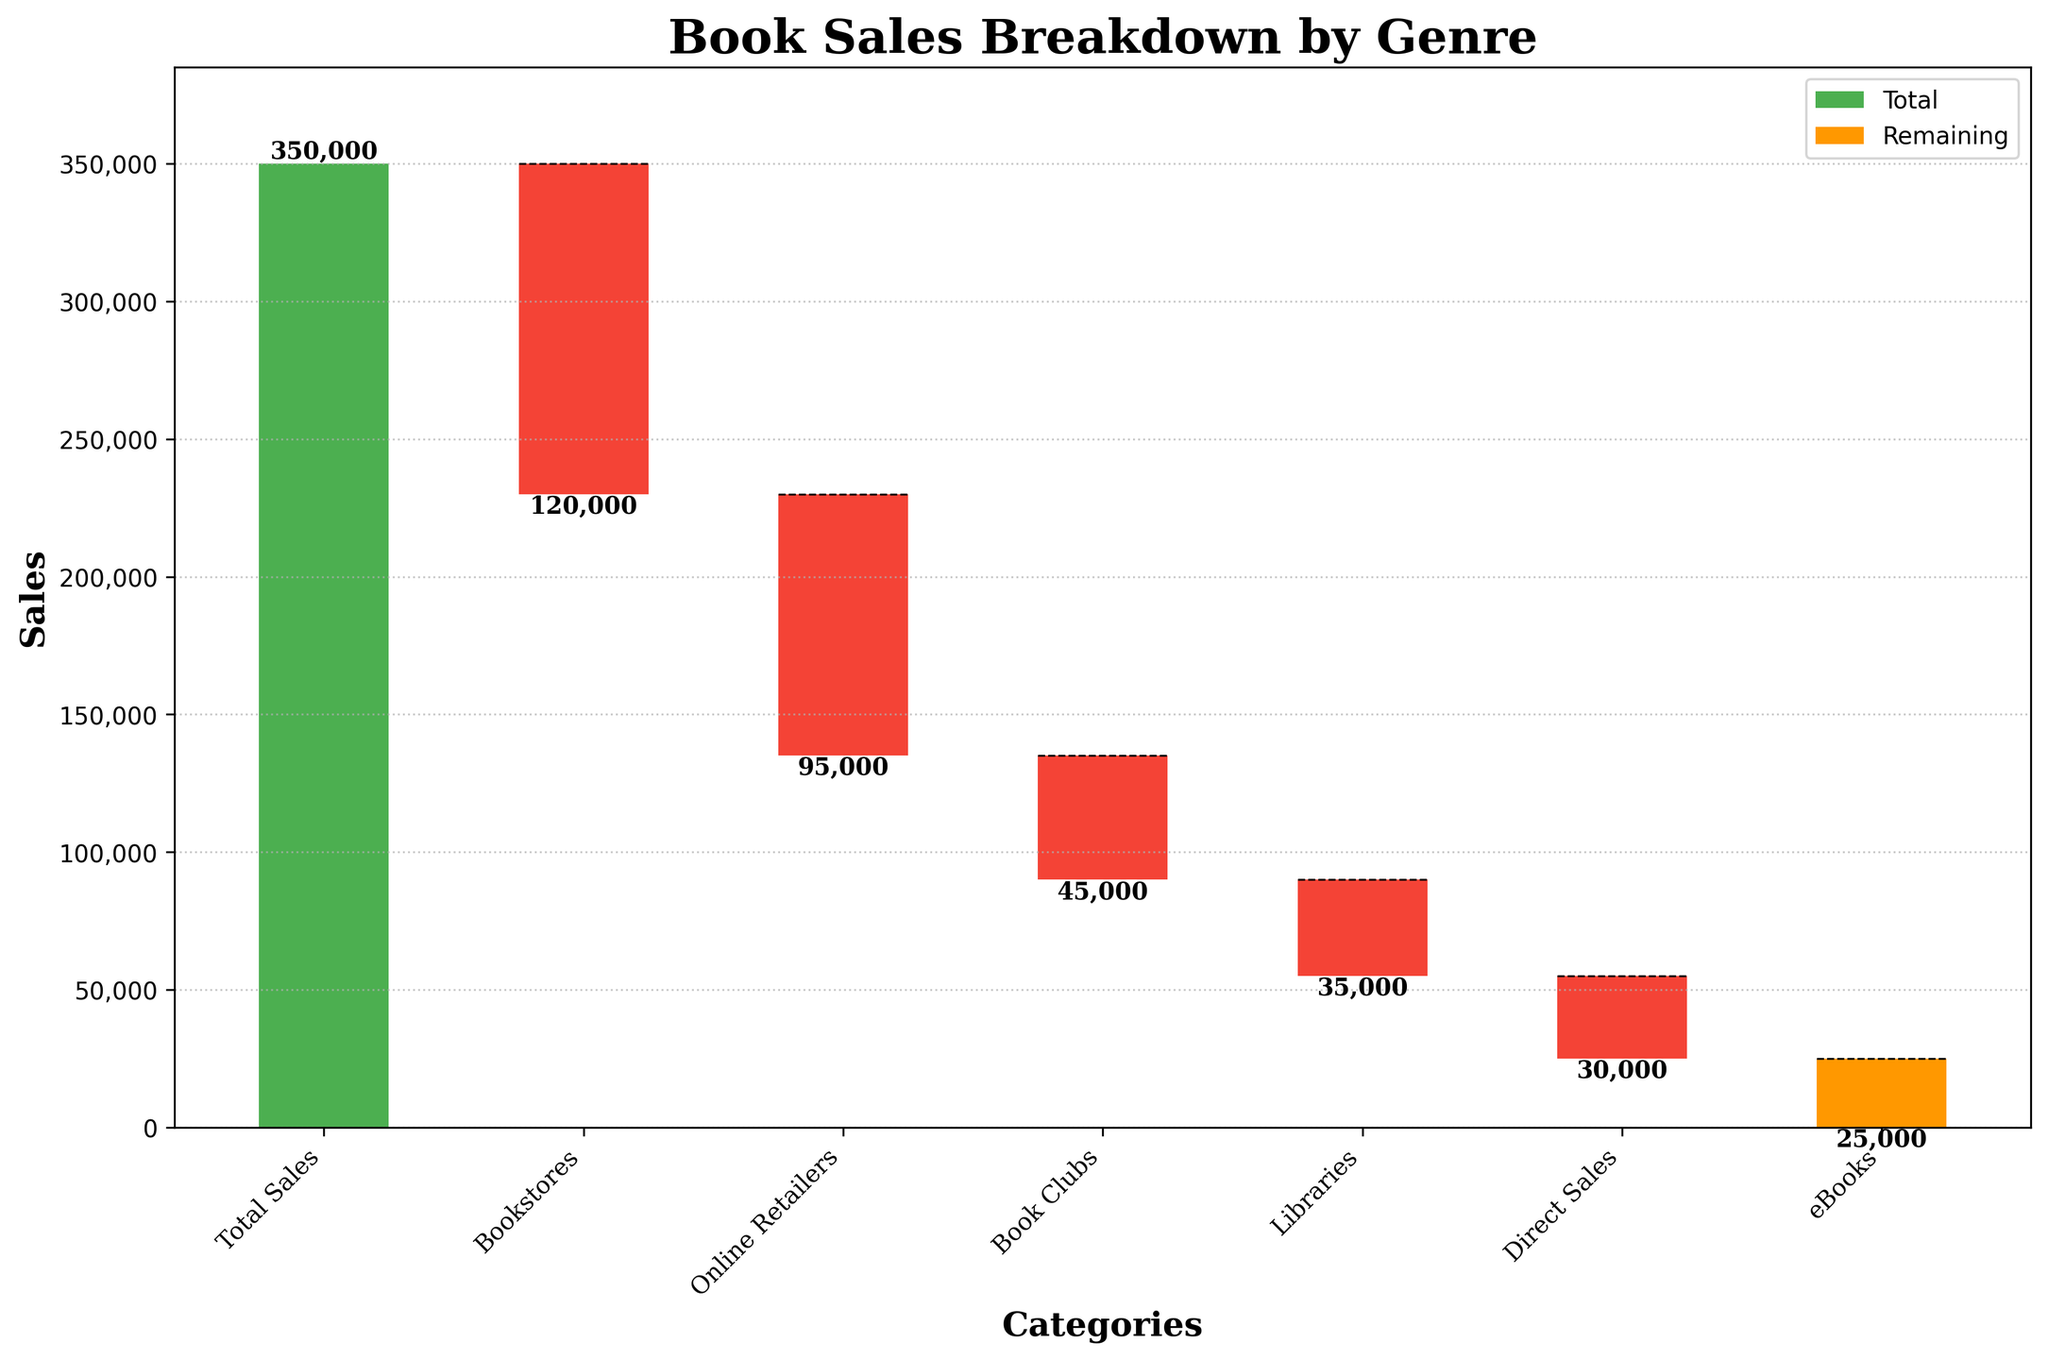What is the total sales value for the book? The total sales value is shown by the first bar labeled "Total Sales".
Answer: 350,000 What are the categories shown on the x-axis? The categories on the x-axis are labeled at the bottom of the bars.
Answer: Total Sales, Bookstores, Online Retailers, Book Clubs, Libraries, Direct Sales, eBooks Which category has the largest sales reduction? By comparing the negative values shown on the bars, the category with the largest reduction is "Bookstores" with -120,000.
Answer: Bookstores How much do Online Retailers and Book Clubs contribute to the sales reduction combined? The reduction from Online Retailers is -95,000 and from Book Clubs is -45,000. Adding these together: -95,000 + -45,000 = -140,000.
Answer: -140,000 What is the cumulative value after Direct Sales? The cumulative value before Direct Sales can be found by summing all the previous values, but using the plot, it shows that after Direct Sales, the value is cumulative up to that point. This is illustrated visually and should be read directly from the end of the "Direct Sales" bar.
Answer: 35,000 Which category has the smallest sales reduction? Comparing all the negative bars, "eBooks" has the smallest reduction with -25,000.
Answer: eBooks What percentage of the total sales is represented by the reduction from Libraries? The reduction from Libraries is -35,000. To find the percentage: (-35,000 / 350,000) * 100%.
Answer: 10% How are the bars color-coded in the chart? The first bar "Total Sales" is shown in green, intermediate bars in red, and the final bar "eBooks" in orange.
Answer: Green, Red, Orange What is the visual difference between the first bar and the subsequent bars in terms of style? The first bar is entirely above the x-axis representing the total sales, while subsequent bars drop below the x-axis indicating sales reductions.
Answer: First above, others below What is the reduction in sales when combining Bookstores, Direct Sales, and eBooks? The reductions are: Bookstores (-120,000), Direct Sales (-30,000), and eBooks (-25,000). Combined, the reduction is -120,000 - 30,000 - 25,000 = -175,000.
Answer: -175,000 